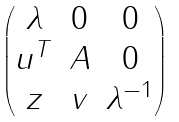Convert formula to latex. <formula><loc_0><loc_0><loc_500><loc_500>\begin{pmatrix} \lambda & 0 & 0 \\ u ^ { T } & A & 0 \\ z & v & \lambda ^ { - 1 } \end{pmatrix}</formula> 